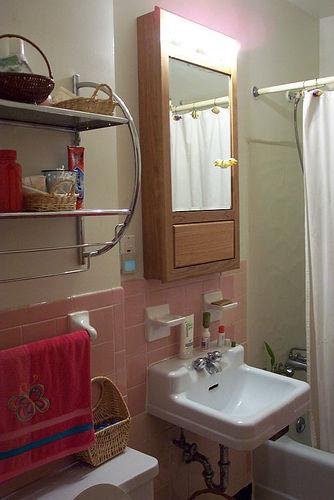Do you see any toothbrushes in this bathroom?
Concise answer only. No. Is this bathroom clean?
Quick response, please. Yes. What is the cabinet made of?
Be succinct. Wood. What animal is on the towel?
Keep it brief. Butterfly. Does the sink need to be repaired?
Concise answer only. No. 